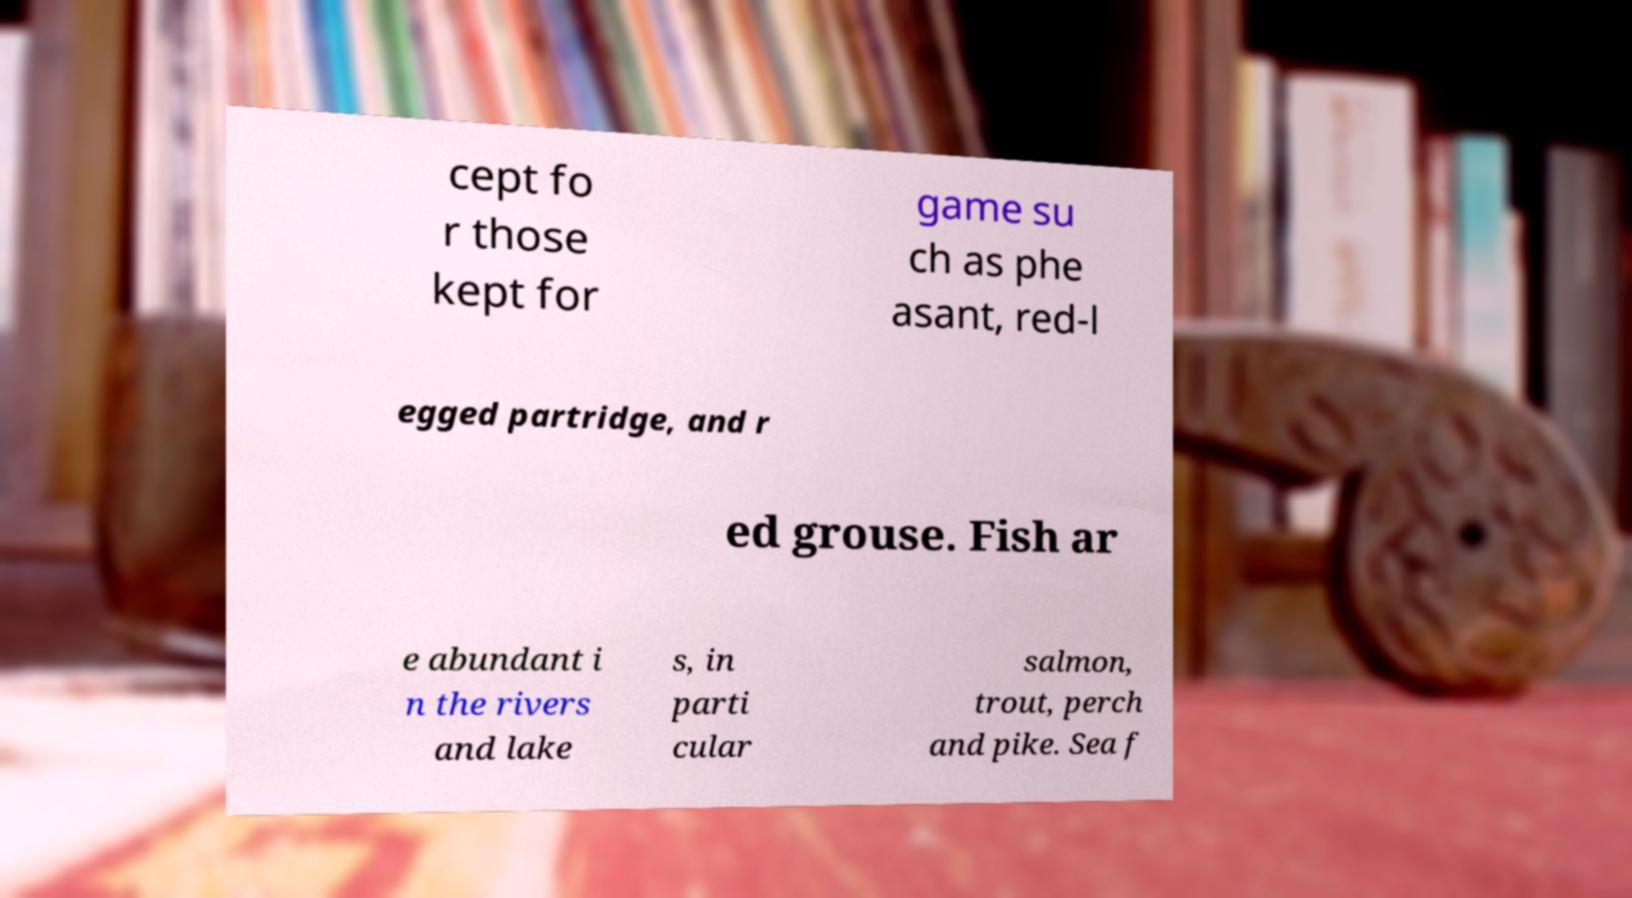For documentation purposes, I need the text within this image transcribed. Could you provide that? cept fo r those kept for game su ch as phe asant, red-l egged partridge, and r ed grouse. Fish ar e abundant i n the rivers and lake s, in parti cular salmon, trout, perch and pike. Sea f 